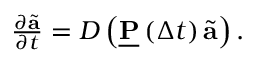<formula> <loc_0><loc_0><loc_500><loc_500>\begin{array} { r } { \frac { \partial \tilde { a } } { \partial t } = D \left ( \underline { P } \left ( \Delta t \right ) \tilde { a } \right ) . } \end{array}</formula> 